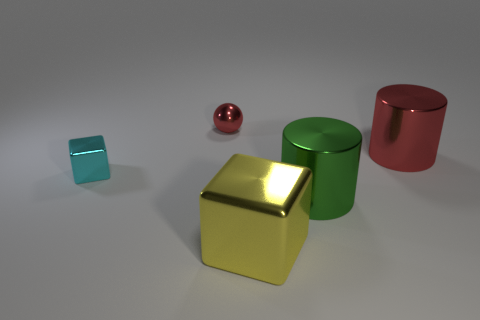Add 3 red objects. How many objects exist? 8 Subtract all cylinders. How many objects are left? 3 Subtract 1 yellow cubes. How many objects are left? 4 Subtract all large yellow shiny cylinders. Subtract all shiny balls. How many objects are left? 4 Add 2 tiny metallic objects. How many tiny metallic objects are left? 4 Add 5 green cylinders. How many green cylinders exist? 6 